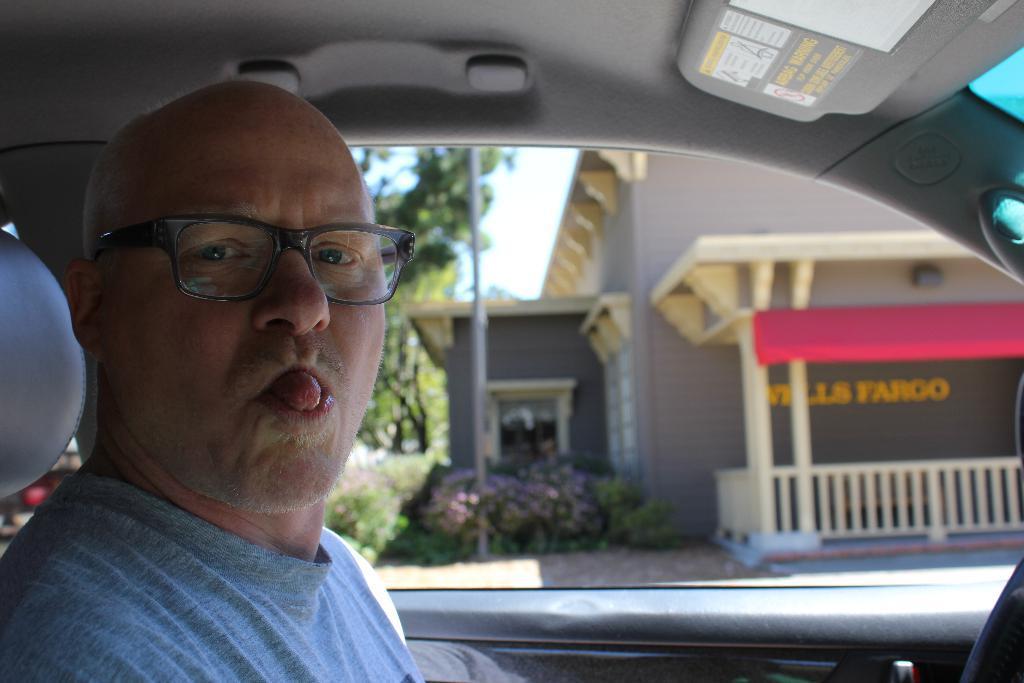Please provide a concise description of this image. In this image we can see a man sitting inside the car and in the background there are some trees plants and a building. 